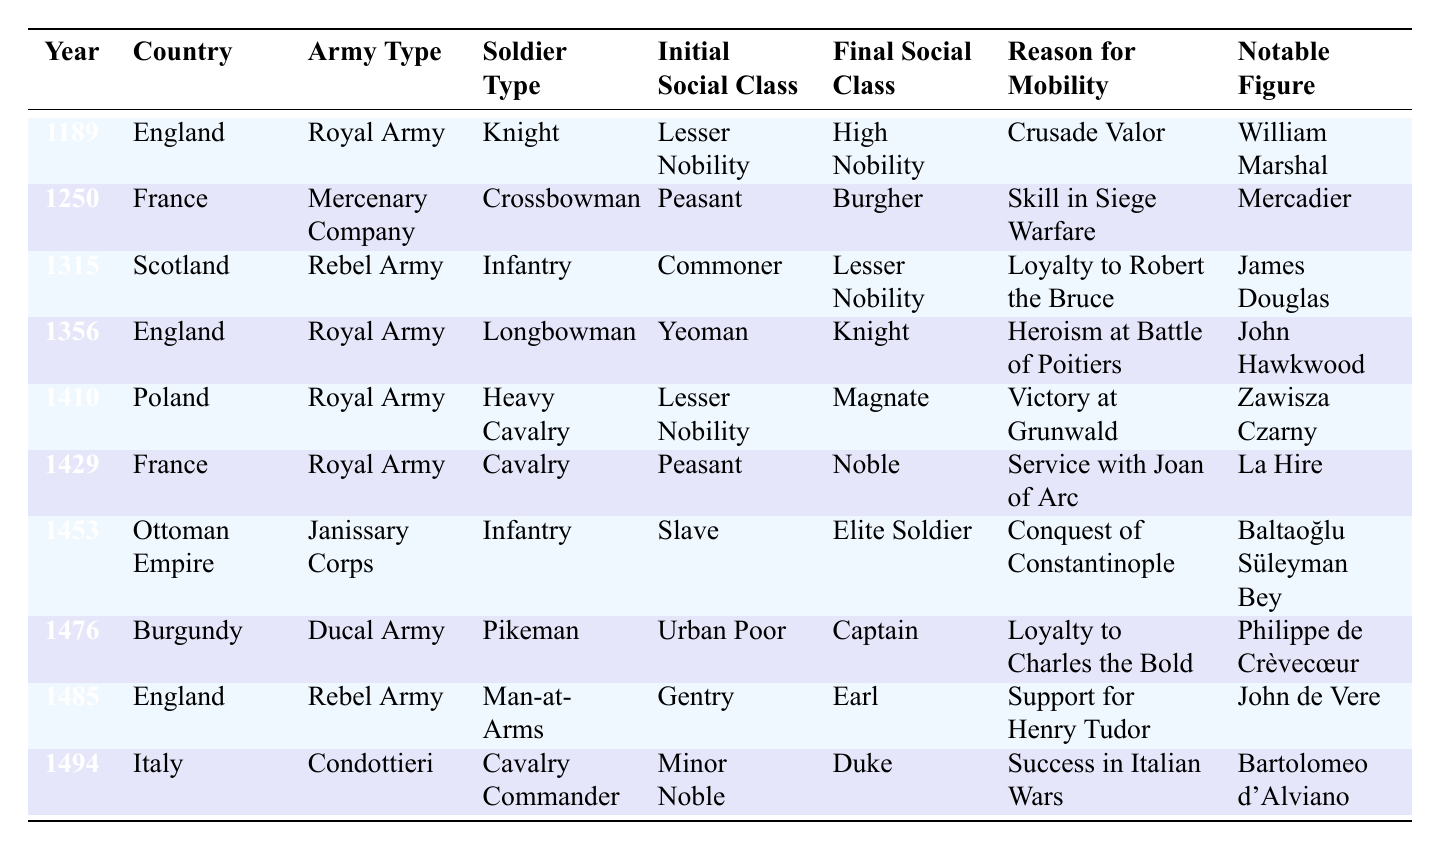What year did William Marshal achieve social mobility? William Marshal is mentioned in the table for the year 1189 under the Royal Army in England, where he moved from Lesser Nobility to High Nobility.
Answer: 1189 In which country did a peasant become a noble due to service with Joan of Arc? The table indicates that in France in 1429, a peasant became a noble as a result of service with Joan of Arc.
Answer: France What was the initial social class of Baltaoğlu Süleyman Bey? The table shows that Baltaoğlu Süleyman Bey, who served in the Ottoman Empire’s Janissary Corps in 1453, started as a slave.
Answer: Slave How many soldiers in the table achieved a final social class of noble? By reviewing the final social classes listed, we see that La Hire (France, 1429), Zawisza Czarny (Poland, 1410), and Baltaoğlu Süleyman Bey (Ottoman Empire, 1453) all achieved noble status along with the Lesser Nobility listed. There are three distinct entries achieving noble class status.
Answer: 3 Which army type had soldiers from both peasant and commoner backgrounds achieve elevated social status? The table shows that both the Royal Army in England (Longbowman) and the Royal Army in France (Cavalry) had soldiers from peasant and commoner backgrounds who achieved elevated status—knightly and noble respectively.
Answer: Royal Army What was the notable figure associated with the year 1494, and what social class did they achieve? The notable figure in 1494 is Bartolomeo d'Alviano, who advanced from a minor noble to a duke.
Answer: Bartolomeo d'Alviano; Duke Did any soldiers in the table start as urban poor and achieve captain status? The table indicates that Philippe de Crèvecœur from Burgundy in 1476, started as urban poor and achieved the rank of captain, confirming the statement to be true.
Answer: Yes What is the difference in social class advancement for soldiers from England and those from the Ottoman Empire? In England, soldiers moved from Lesser Nobility to High Nobility (William Marshal) and from Yeoman to Knight (John Hawkwood); whereas in the Ottoman Empire, soldiers like Baltaoğlu Süleyman Bey advanced from Slave to Elite Soldier, showing significant advancement, but in two different contexts of warfare and society. The difference is that England saw stepwise nobility, whereas the Ottoman model promoted skilled slaves directly to elite status.
Answer: England: Knight; Ottoman Empire: Elite Soldier How many different countries are represented in the table? The table lists soldiers from England, France, Scotland, Poland, the Ottoman Empire, Burgundy, and Italy, totaling seven distinct countries.
Answer: 7 Which soldier type showed the most significant upward mobility in terms of social class in the table? Analyzing the table, Baltaoğlu Süleyman Bey's trajectory from Slave to Elite Soldier reflects significant upward mobility in terms of class. Other notable advancements are William Marshal and Bartolomeo d'Alviano. Comparing total social class jumps shows Baltaoğlu had the largest shift magnitude wise compared to his origin.
Answer: Baltaoğlu Süleyman Bey How many soldiers became members of the nobility after serving in the Royal Army? By reviewing the entries, La Hire and Zawisza Czarny both achieved noble status from the Royal Army, confirming the total members who transitioned to nobility there is two.
Answer: 2 